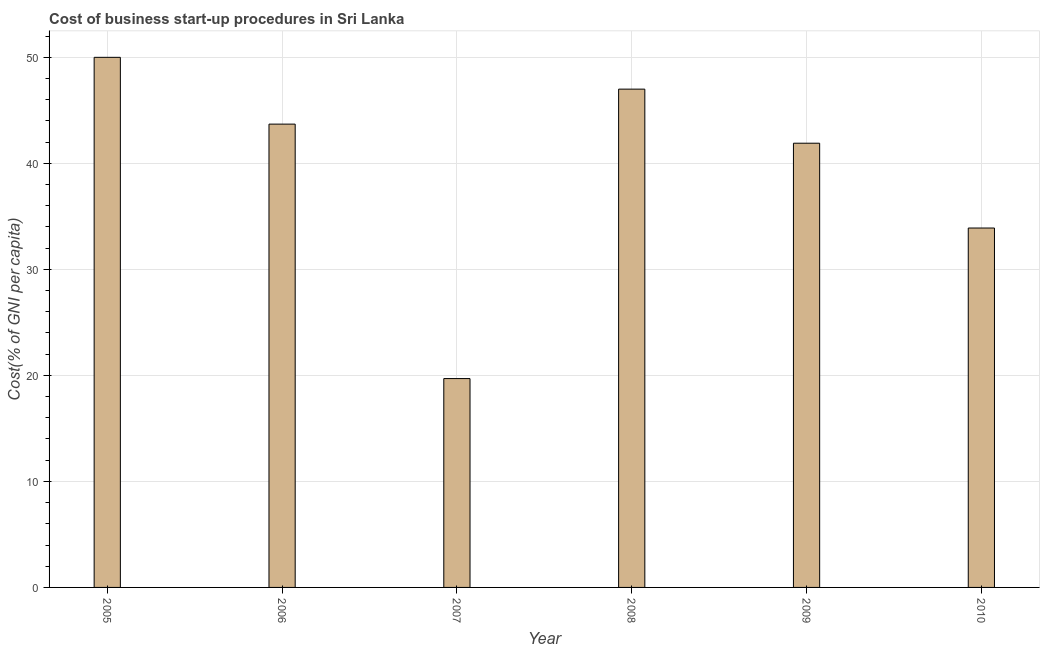Does the graph contain any zero values?
Keep it short and to the point. No. Does the graph contain grids?
Make the answer very short. Yes. What is the title of the graph?
Your response must be concise. Cost of business start-up procedures in Sri Lanka. What is the label or title of the Y-axis?
Your answer should be compact. Cost(% of GNI per capita). What is the cost of business startup procedures in 2006?
Make the answer very short. 43.7. What is the sum of the cost of business startup procedures?
Your answer should be compact. 236.2. What is the difference between the cost of business startup procedures in 2006 and 2007?
Your answer should be very brief. 24. What is the average cost of business startup procedures per year?
Ensure brevity in your answer.  39.37. What is the median cost of business startup procedures?
Offer a terse response. 42.8. In how many years, is the cost of business startup procedures greater than 26 %?
Your answer should be very brief. 5. What is the ratio of the cost of business startup procedures in 2007 to that in 2008?
Make the answer very short. 0.42. Is the difference between the cost of business startup procedures in 2007 and 2008 greater than the difference between any two years?
Make the answer very short. No. What is the difference between the highest and the second highest cost of business startup procedures?
Ensure brevity in your answer.  3. Is the sum of the cost of business startup procedures in 2008 and 2010 greater than the maximum cost of business startup procedures across all years?
Your answer should be very brief. Yes. What is the difference between the highest and the lowest cost of business startup procedures?
Provide a short and direct response. 30.3. Are all the bars in the graph horizontal?
Provide a succinct answer. No. How many years are there in the graph?
Keep it short and to the point. 6. What is the Cost(% of GNI per capita) of 2005?
Your answer should be compact. 50. What is the Cost(% of GNI per capita) of 2006?
Provide a short and direct response. 43.7. What is the Cost(% of GNI per capita) in 2008?
Make the answer very short. 47. What is the Cost(% of GNI per capita) of 2009?
Provide a short and direct response. 41.9. What is the Cost(% of GNI per capita) of 2010?
Provide a succinct answer. 33.9. What is the difference between the Cost(% of GNI per capita) in 2005 and 2006?
Your response must be concise. 6.3. What is the difference between the Cost(% of GNI per capita) in 2005 and 2007?
Your answer should be compact. 30.3. What is the difference between the Cost(% of GNI per capita) in 2005 and 2009?
Ensure brevity in your answer.  8.1. What is the difference between the Cost(% of GNI per capita) in 2007 and 2008?
Make the answer very short. -27.3. What is the difference between the Cost(% of GNI per capita) in 2007 and 2009?
Your answer should be compact. -22.2. What is the difference between the Cost(% of GNI per capita) in 2008 and 2009?
Ensure brevity in your answer.  5.1. What is the difference between the Cost(% of GNI per capita) in 2008 and 2010?
Keep it short and to the point. 13.1. What is the ratio of the Cost(% of GNI per capita) in 2005 to that in 2006?
Give a very brief answer. 1.14. What is the ratio of the Cost(% of GNI per capita) in 2005 to that in 2007?
Keep it short and to the point. 2.54. What is the ratio of the Cost(% of GNI per capita) in 2005 to that in 2008?
Your response must be concise. 1.06. What is the ratio of the Cost(% of GNI per capita) in 2005 to that in 2009?
Give a very brief answer. 1.19. What is the ratio of the Cost(% of GNI per capita) in 2005 to that in 2010?
Provide a succinct answer. 1.48. What is the ratio of the Cost(% of GNI per capita) in 2006 to that in 2007?
Your answer should be very brief. 2.22. What is the ratio of the Cost(% of GNI per capita) in 2006 to that in 2008?
Your answer should be very brief. 0.93. What is the ratio of the Cost(% of GNI per capita) in 2006 to that in 2009?
Your response must be concise. 1.04. What is the ratio of the Cost(% of GNI per capita) in 2006 to that in 2010?
Offer a very short reply. 1.29. What is the ratio of the Cost(% of GNI per capita) in 2007 to that in 2008?
Ensure brevity in your answer.  0.42. What is the ratio of the Cost(% of GNI per capita) in 2007 to that in 2009?
Your response must be concise. 0.47. What is the ratio of the Cost(% of GNI per capita) in 2007 to that in 2010?
Offer a terse response. 0.58. What is the ratio of the Cost(% of GNI per capita) in 2008 to that in 2009?
Your response must be concise. 1.12. What is the ratio of the Cost(% of GNI per capita) in 2008 to that in 2010?
Keep it short and to the point. 1.39. What is the ratio of the Cost(% of GNI per capita) in 2009 to that in 2010?
Ensure brevity in your answer.  1.24. 